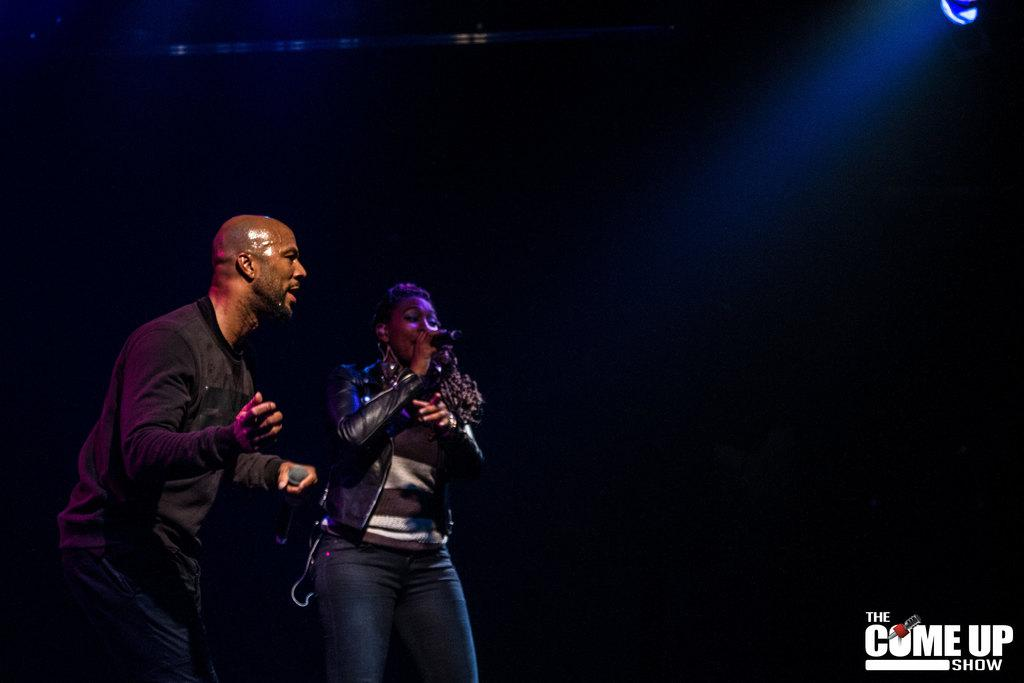What are the people in the image holding? The people in the image are holding mics. What can be seen at the top of the image? There is a light visible at the top of the image. How would you describe the background of the image? The background of the image is dark. What information is provided at the bottom of the image? There is some text written at the bottom of the image. What route are the people taking to reach the committee meeting in the image? There is no indication of a route or committee meeting in the image. 